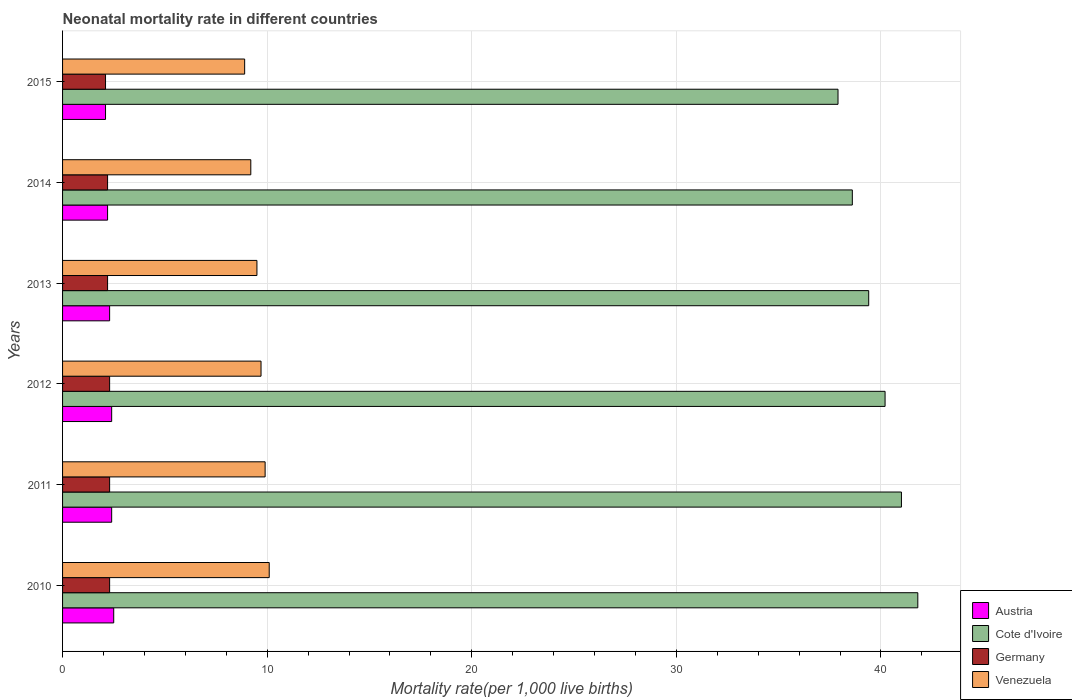Are the number of bars on each tick of the Y-axis equal?
Give a very brief answer. Yes. How many bars are there on the 1st tick from the bottom?
Your response must be concise. 4. What is the label of the 5th group of bars from the top?
Your answer should be compact. 2011. In how many cases, is the number of bars for a given year not equal to the number of legend labels?
Give a very brief answer. 0. What is the neonatal mortality rate in Cote d'Ivoire in 2011?
Offer a terse response. 41. Across all years, what is the minimum neonatal mortality rate in Cote d'Ivoire?
Keep it short and to the point. 37.9. In which year was the neonatal mortality rate in Cote d'Ivoire minimum?
Make the answer very short. 2015. What is the total neonatal mortality rate in Cote d'Ivoire in the graph?
Ensure brevity in your answer.  238.9. What is the difference between the neonatal mortality rate in Cote d'Ivoire in 2012 and that in 2013?
Provide a short and direct response. 0.8. What is the difference between the neonatal mortality rate in Venezuela in 2010 and the neonatal mortality rate in Austria in 2011?
Provide a succinct answer. 7.7. What is the average neonatal mortality rate in Venezuela per year?
Give a very brief answer. 9.55. In the year 2012, what is the difference between the neonatal mortality rate in Cote d'Ivoire and neonatal mortality rate in Germany?
Make the answer very short. 37.9. What is the ratio of the neonatal mortality rate in Austria in 2010 to that in 2011?
Give a very brief answer. 1.04. Is the neonatal mortality rate in Germany in 2010 less than that in 2015?
Your answer should be very brief. No. Is the difference between the neonatal mortality rate in Cote d'Ivoire in 2011 and 2013 greater than the difference between the neonatal mortality rate in Germany in 2011 and 2013?
Give a very brief answer. Yes. What is the difference between the highest and the second highest neonatal mortality rate in Cote d'Ivoire?
Make the answer very short. 0.8. What is the difference between the highest and the lowest neonatal mortality rate in Cote d'Ivoire?
Your answer should be compact. 3.9. In how many years, is the neonatal mortality rate in Cote d'Ivoire greater than the average neonatal mortality rate in Cote d'Ivoire taken over all years?
Keep it short and to the point. 3. Is it the case that in every year, the sum of the neonatal mortality rate in Venezuela and neonatal mortality rate in Germany is greater than the sum of neonatal mortality rate in Austria and neonatal mortality rate in Cote d'Ivoire?
Your response must be concise. Yes. What does the 3rd bar from the bottom in 2012 represents?
Give a very brief answer. Germany. Are all the bars in the graph horizontal?
Provide a short and direct response. Yes. How many years are there in the graph?
Give a very brief answer. 6. What is the difference between two consecutive major ticks on the X-axis?
Make the answer very short. 10. Does the graph contain any zero values?
Give a very brief answer. No. What is the title of the graph?
Your response must be concise. Neonatal mortality rate in different countries. What is the label or title of the X-axis?
Ensure brevity in your answer.  Mortality rate(per 1,0 live births). What is the Mortality rate(per 1,000 live births) of Cote d'Ivoire in 2010?
Give a very brief answer. 41.8. What is the Mortality rate(per 1,000 live births) of Germany in 2010?
Your answer should be very brief. 2.3. What is the Mortality rate(per 1,000 live births) of Cote d'Ivoire in 2011?
Your response must be concise. 41. What is the Mortality rate(per 1,000 live births) of Germany in 2011?
Keep it short and to the point. 2.3. What is the Mortality rate(per 1,000 live births) of Cote d'Ivoire in 2012?
Offer a terse response. 40.2. What is the Mortality rate(per 1,000 live births) of Germany in 2012?
Make the answer very short. 2.3. What is the Mortality rate(per 1,000 live births) in Cote d'Ivoire in 2013?
Make the answer very short. 39.4. What is the Mortality rate(per 1,000 live births) of Germany in 2013?
Your answer should be compact. 2.2. What is the Mortality rate(per 1,000 live births) in Venezuela in 2013?
Make the answer very short. 9.5. What is the Mortality rate(per 1,000 live births) of Cote d'Ivoire in 2014?
Your answer should be compact. 38.6. What is the Mortality rate(per 1,000 live births) of Cote d'Ivoire in 2015?
Offer a very short reply. 37.9. What is the Mortality rate(per 1,000 live births) of Germany in 2015?
Offer a very short reply. 2.1. What is the Mortality rate(per 1,000 live births) of Venezuela in 2015?
Provide a succinct answer. 8.9. Across all years, what is the maximum Mortality rate(per 1,000 live births) of Austria?
Give a very brief answer. 2.5. Across all years, what is the maximum Mortality rate(per 1,000 live births) in Cote d'Ivoire?
Offer a terse response. 41.8. Across all years, what is the maximum Mortality rate(per 1,000 live births) in Germany?
Provide a succinct answer. 2.3. Across all years, what is the maximum Mortality rate(per 1,000 live births) of Venezuela?
Make the answer very short. 10.1. Across all years, what is the minimum Mortality rate(per 1,000 live births) in Austria?
Make the answer very short. 2.1. Across all years, what is the minimum Mortality rate(per 1,000 live births) in Cote d'Ivoire?
Provide a succinct answer. 37.9. Across all years, what is the minimum Mortality rate(per 1,000 live births) of Venezuela?
Your response must be concise. 8.9. What is the total Mortality rate(per 1,000 live births) of Cote d'Ivoire in the graph?
Ensure brevity in your answer.  238.9. What is the total Mortality rate(per 1,000 live births) of Venezuela in the graph?
Your answer should be compact. 57.3. What is the difference between the Mortality rate(per 1,000 live births) of Germany in 2010 and that in 2011?
Provide a succinct answer. 0. What is the difference between the Mortality rate(per 1,000 live births) of Austria in 2010 and that in 2012?
Give a very brief answer. 0.1. What is the difference between the Mortality rate(per 1,000 live births) of Cote d'Ivoire in 2010 and that in 2012?
Make the answer very short. 1.6. What is the difference between the Mortality rate(per 1,000 live births) in Venezuela in 2010 and that in 2012?
Ensure brevity in your answer.  0.4. What is the difference between the Mortality rate(per 1,000 live births) in Germany in 2010 and that in 2013?
Keep it short and to the point. 0.1. What is the difference between the Mortality rate(per 1,000 live births) of Cote d'Ivoire in 2010 and that in 2014?
Provide a succinct answer. 3.2. What is the difference between the Mortality rate(per 1,000 live births) in Germany in 2010 and that in 2014?
Your answer should be very brief. 0.1. What is the difference between the Mortality rate(per 1,000 live births) in Venezuela in 2010 and that in 2014?
Offer a terse response. 0.9. What is the difference between the Mortality rate(per 1,000 live births) in Austria in 2010 and that in 2015?
Make the answer very short. 0.4. What is the difference between the Mortality rate(per 1,000 live births) in Germany in 2010 and that in 2015?
Your response must be concise. 0.2. What is the difference between the Mortality rate(per 1,000 live births) in Austria in 2011 and that in 2013?
Keep it short and to the point. 0.1. What is the difference between the Mortality rate(per 1,000 live births) in Germany in 2011 and that in 2013?
Provide a succinct answer. 0.1. What is the difference between the Mortality rate(per 1,000 live births) in Venezuela in 2011 and that in 2013?
Ensure brevity in your answer.  0.4. What is the difference between the Mortality rate(per 1,000 live births) in Cote d'Ivoire in 2011 and that in 2014?
Give a very brief answer. 2.4. What is the difference between the Mortality rate(per 1,000 live births) of Germany in 2011 and that in 2014?
Give a very brief answer. 0.1. What is the difference between the Mortality rate(per 1,000 live births) of Cote d'Ivoire in 2011 and that in 2015?
Provide a succinct answer. 3.1. What is the difference between the Mortality rate(per 1,000 live births) in Venezuela in 2011 and that in 2015?
Offer a very short reply. 1. What is the difference between the Mortality rate(per 1,000 live births) of Cote d'Ivoire in 2012 and that in 2013?
Give a very brief answer. 0.8. What is the difference between the Mortality rate(per 1,000 live births) of Germany in 2012 and that in 2013?
Keep it short and to the point. 0.1. What is the difference between the Mortality rate(per 1,000 live births) of Venezuela in 2012 and that in 2013?
Make the answer very short. 0.2. What is the difference between the Mortality rate(per 1,000 live births) of Austria in 2012 and that in 2014?
Your answer should be compact. 0.2. What is the difference between the Mortality rate(per 1,000 live births) in Cote d'Ivoire in 2012 and that in 2014?
Your response must be concise. 1.6. What is the difference between the Mortality rate(per 1,000 live births) in Germany in 2012 and that in 2014?
Provide a short and direct response. 0.1. What is the difference between the Mortality rate(per 1,000 live births) of Venezuela in 2012 and that in 2014?
Your answer should be compact. 0.5. What is the difference between the Mortality rate(per 1,000 live births) in Cote d'Ivoire in 2012 and that in 2015?
Provide a short and direct response. 2.3. What is the difference between the Mortality rate(per 1,000 live births) of Germany in 2012 and that in 2015?
Your response must be concise. 0.2. What is the difference between the Mortality rate(per 1,000 live births) in Cote d'Ivoire in 2013 and that in 2014?
Your response must be concise. 0.8. What is the difference between the Mortality rate(per 1,000 live births) of Germany in 2013 and that in 2014?
Your response must be concise. 0. What is the difference between the Mortality rate(per 1,000 live births) of Venezuela in 2013 and that in 2014?
Provide a short and direct response. 0.3. What is the difference between the Mortality rate(per 1,000 live births) in Cote d'Ivoire in 2013 and that in 2015?
Your response must be concise. 1.5. What is the difference between the Mortality rate(per 1,000 live births) of Venezuela in 2013 and that in 2015?
Keep it short and to the point. 0.6. What is the difference between the Mortality rate(per 1,000 live births) in Germany in 2014 and that in 2015?
Provide a succinct answer. 0.1. What is the difference between the Mortality rate(per 1,000 live births) in Venezuela in 2014 and that in 2015?
Provide a short and direct response. 0.3. What is the difference between the Mortality rate(per 1,000 live births) in Austria in 2010 and the Mortality rate(per 1,000 live births) in Cote d'Ivoire in 2011?
Your answer should be compact. -38.5. What is the difference between the Mortality rate(per 1,000 live births) of Austria in 2010 and the Mortality rate(per 1,000 live births) of Germany in 2011?
Offer a terse response. 0.2. What is the difference between the Mortality rate(per 1,000 live births) of Cote d'Ivoire in 2010 and the Mortality rate(per 1,000 live births) of Germany in 2011?
Your answer should be compact. 39.5. What is the difference between the Mortality rate(per 1,000 live births) in Cote d'Ivoire in 2010 and the Mortality rate(per 1,000 live births) in Venezuela in 2011?
Provide a short and direct response. 31.9. What is the difference between the Mortality rate(per 1,000 live births) of Austria in 2010 and the Mortality rate(per 1,000 live births) of Cote d'Ivoire in 2012?
Your response must be concise. -37.7. What is the difference between the Mortality rate(per 1,000 live births) of Austria in 2010 and the Mortality rate(per 1,000 live births) of Venezuela in 2012?
Make the answer very short. -7.2. What is the difference between the Mortality rate(per 1,000 live births) of Cote d'Ivoire in 2010 and the Mortality rate(per 1,000 live births) of Germany in 2012?
Make the answer very short. 39.5. What is the difference between the Mortality rate(per 1,000 live births) in Cote d'Ivoire in 2010 and the Mortality rate(per 1,000 live births) in Venezuela in 2012?
Your answer should be very brief. 32.1. What is the difference between the Mortality rate(per 1,000 live births) in Austria in 2010 and the Mortality rate(per 1,000 live births) in Cote d'Ivoire in 2013?
Provide a succinct answer. -36.9. What is the difference between the Mortality rate(per 1,000 live births) of Austria in 2010 and the Mortality rate(per 1,000 live births) of Germany in 2013?
Your answer should be compact. 0.3. What is the difference between the Mortality rate(per 1,000 live births) in Cote d'Ivoire in 2010 and the Mortality rate(per 1,000 live births) in Germany in 2013?
Your answer should be very brief. 39.6. What is the difference between the Mortality rate(per 1,000 live births) of Cote d'Ivoire in 2010 and the Mortality rate(per 1,000 live births) of Venezuela in 2013?
Ensure brevity in your answer.  32.3. What is the difference between the Mortality rate(per 1,000 live births) of Austria in 2010 and the Mortality rate(per 1,000 live births) of Cote d'Ivoire in 2014?
Provide a succinct answer. -36.1. What is the difference between the Mortality rate(per 1,000 live births) in Austria in 2010 and the Mortality rate(per 1,000 live births) in Germany in 2014?
Your response must be concise. 0.3. What is the difference between the Mortality rate(per 1,000 live births) in Cote d'Ivoire in 2010 and the Mortality rate(per 1,000 live births) in Germany in 2014?
Make the answer very short. 39.6. What is the difference between the Mortality rate(per 1,000 live births) of Cote d'Ivoire in 2010 and the Mortality rate(per 1,000 live births) of Venezuela in 2014?
Keep it short and to the point. 32.6. What is the difference between the Mortality rate(per 1,000 live births) in Austria in 2010 and the Mortality rate(per 1,000 live births) in Cote d'Ivoire in 2015?
Keep it short and to the point. -35.4. What is the difference between the Mortality rate(per 1,000 live births) of Austria in 2010 and the Mortality rate(per 1,000 live births) of Germany in 2015?
Provide a succinct answer. 0.4. What is the difference between the Mortality rate(per 1,000 live births) in Austria in 2010 and the Mortality rate(per 1,000 live births) in Venezuela in 2015?
Offer a terse response. -6.4. What is the difference between the Mortality rate(per 1,000 live births) in Cote d'Ivoire in 2010 and the Mortality rate(per 1,000 live births) in Germany in 2015?
Provide a short and direct response. 39.7. What is the difference between the Mortality rate(per 1,000 live births) of Cote d'Ivoire in 2010 and the Mortality rate(per 1,000 live births) of Venezuela in 2015?
Your answer should be compact. 32.9. What is the difference between the Mortality rate(per 1,000 live births) in Germany in 2010 and the Mortality rate(per 1,000 live births) in Venezuela in 2015?
Your response must be concise. -6.6. What is the difference between the Mortality rate(per 1,000 live births) of Austria in 2011 and the Mortality rate(per 1,000 live births) of Cote d'Ivoire in 2012?
Provide a short and direct response. -37.8. What is the difference between the Mortality rate(per 1,000 live births) of Cote d'Ivoire in 2011 and the Mortality rate(per 1,000 live births) of Germany in 2012?
Provide a short and direct response. 38.7. What is the difference between the Mortality rate(per 1,000 live births) of Cote d'Ivoire in 2011 and the Mortality rate(per 1,000 live births) of Venezuela in 2012?
Provide a short and direct response. 31.3. What is the difference between the Mortality rate(per 1,000 live births) of Germany in 2011 and the Mortality rate(per 1,000 live births) of Venezuela in 2012?
Provide a succinct answer. -7.4. What is the difference between the Mortality rate(per 1,000 live births) of Austria in 2011 and the Mortality rate(per 1,000 live births) of Cote d'Ivoire in 2013?
Keep it short and to the point. -37. What is the difference between the Mortality rate(per 1,000 live births) of Cote d'Ivoire in 2011 and the Mortality rate(per 1,000 live births) of Germany in 2013?
Provide a succinct answer. 38.8. What is the difference between the Mortality rate(per 1,000 live births) of Cote d'Ivoire in 2011 and the Mortality rate(per 1,000 live births) of Venezuela in 2013?
Ensure brevity in your answer.  31.5. What is the difference between the Mortality rate(per 1,000 live births) in Germany in 2011 and the Mortality rate(per 1,000 live births) in Venezuela in 2013?
Provide a succinct answer. -7.2. What is the difference between the Mortality rate(per 1,000 live births) of Austria in 2011 and the Mortality rate(per 1,000 live births) of Cote d'Ivoire in 2014?
Give a very brief answer. -36.2. What is the difference between the Mortality rate(per 1,000 live births) of Cote d'Ivoire in 2011 and the Mortality rate(per 1,000 live births) of Germany in 2014?
Offer a very short reply. 38.8. What is the difference between the Mortality rate(per 1,000 live births) of Cote d'Ivoire in 2011 and the Mortality rate(per 1,000 live births) of Venezuela in 2014?
Your response must be concise. 31.8. What is the difference between the Mortality rate(per 1,000 live births) in Germany in 2011 and the Mortality rate(per 1,000 live births) in Venezuela in 2014?
Offer a terse response. -6.9. What is the difference between the Mortality rate(per 1,000 live births) of Austria in 2011 and the Mortality rate(per 1,000 live births) of Cote d'Ivoire in 2015?
Give a very brief answer. -35.5. What is the difference between the Mortality rate(per 1,000 live births) in Austria in 2011 and the Mortality rate(per 1,000 live births) in Germany in 2015?
Your answer should be compact. 0.3. What is the difference between the Mortality rate(per 1,000 live births) of Austria in 2011 and the Mortality rate(per 1,000 live births) of Venezuela in 2015?
Ensure brevity in your answer.  -6.5. What is the difference between the Mortality rate(per 1,000 live births) of Cote d'Ivoire in 2011 and the Mortality rate(per 1,000 live births) of Germany in 2015?
Offer a terse response. 38.9. What is the difference between the Mortality rate(per 1,000 live births) of Cote d'Ivoire in 2011 and the Mortality rate(per 1,000 live births) of Venezuela in 2015?
Keep it short and to the point. 32.1. What is the difference between the Mortality rate(per 1,000 live births) of Germany in 2011 and the Mortality rate(per 1,000 live births) of Venezuela in 2015?
Your response must be concise. -6.6. What is the difference between the Mortality rate(per 1,000 live births) in Austria in 2012 and the Mortality rate(per 1,000 live births) in Cote d'Ivoire in 2013?
Provide a short and direct response. -37. What is the difference between the Mortality rate(per 1,000 live births) in Cote d'Ivoire in 2012 and the Mortality rate(per 1,000 live births) in Venezuela in 2013?
Keep it short and to the point. 30.7. What is the difference between the Mortality rate(per 1,000 live births) of Austria in 2012 and the Mortality rate(per 1,000 live births) of Cote d'Ivoire in 2014?
Offer a terse response. -36.2. What is the difference between the Mortality rate(per 1,000 live births) of Austria in 2012 and the Mortality rate(per 1,000 live births) of Germany in 2014?
Your answer should be very brief. 0.2. What is the difference between the Mortality rate(per 1,000 live births) of Austria in 2012 and the Mortality rate(per 1,000 live births) of Venezuela in 2014?
Provide a succinct answer. -6.8. What is the difference between the Mortality rate(per 1,000 live births) in Cote d'Ivoire in 2012 and the Mortality rate(per 1,000 live births) in Germany in 2014?
Give a very brief answer. 38. What is the difference between the Mortality rate(per 1,000 live births) in Austria in 2012 and the Mortality rate(per 1,000 live births) in Cote d'Ivoire in 2015?
Offer a very short reply. -35.5. What is the difference between the Mortality rate(per 1,000 live births) in Austria in 2012 and the Mortality rate(per 1,000 live births) in Germany in 2015?
Keep it short and to the point. 0.3. What is the difference between the Mortality rate(per 1,000 live births) in Austria in 2012 and the Mortality rate(per 1,000 live births) in Venezuela in 2015?
Make the answer very short. -6.5. What is the difference between the Mortality rate(per 1,000 live births) in Cote d'Ivoire in 2012 and the Mortality rate(per 1,000 live births) in Germany in 2015?
Provide a succinct answer. 38.1. What is the difference between the Mortality rate(per 1,000 live births) in Cote d'Ivoire in 2012 and the Mortality rate(per 1,000 live births) in Venezuela in 2015?
Keep it short and to the point. 31.3. What is the difference between the Mortality rate(per 1,000 live births) in Germany in 2012 and the Mortality rate(per 1,000 live births) in Venezuela in 2015?
Offer a very short reply. -6.6. What is the difference between the Mortality rate(per 1,000 live births) of Austria in 2013 and the Mortality rate(per 1,000 live births) of Cote d'Ivoire in 2014?
Keep it short and to the point. -36.3. What is the difference between the Mortality rate(per 1,000 live births) of Austria in 2013 and the Mortality rate(per 1,000 live births) of Germany in 2014?
Provide a short and direct response. 0.1. What is the difference between the Mortality rate(per 1,000 live births) in Austria in 2013 and the Mortality rate(per 1,000 live births) in Venezuela in 2014?
Provide a short and direct response. -6.9. What is the difference between the Mortality rate(per 1,000 live births) in Cote d'Ivoire in 2013 and the Mortality rate(per 1,000 live births) in Germany in 2014?
Provide a succinct answer. 37.2. What is the difference between the Mortality rate(per 1,000 live births) in Cote d'Ivoire in 2013 and the Mortality rate(per 1,000 live births) in Venezuela in 2014?
Offer a terse response. 30.2. What is the difference between the Mortality rate(per 1,000 live births) in Austria in 2013 and the Mortality rate(per 1,000 live births) in Cote d'Ivoire in 2015?
Your response must be concise. -35.6. What is the difference between the Mortality rate(per 1,000 live births) of Austria in 2013 and the Mortality rate(per 1,000 live births) of Germany in 2015?
Keep it short and to the point. 0.2. What is the difference between the Mortality rate(per 1,000 live births) in Cote d'Ivoire in 2013 and the Mortality rate(per 1,000 live births) in Germany in 2015?
Make the answer very short. 37.3. What is the difference between the Mortality rate(per 1,000 live births) in Cote d'Ivoire in 2013 and the Mortality rate(per 1,000 live births) in Venezuela in 2015?
Provide a short and direct response. 30.5. What is the difference between the Mortality rate(per 1,000 live births) in Austria in 2014 and the Mortality rate(per 1,000 live births) in Cote d'Ivoire in 2015?
Provide a succinct answer. -35.7. What is the difference between the Mortality rate(per 1,000 live births) in Austria in 2014 and the Mortality rate(per 1,000 live births) in Germany in 2015?
Your answer should be compact. 0.1. What is the difference between the Mortality rate(per 1,000 live births) in Cote d'Ivoire in 2014 and the Mortality rate(per 1,000 live births) in Germany in 2015?
Give a very brief answer. 36.5. What is the difference between the Mortality rate(per 1,000 live births) in Cote d'Ivoire in 2014 and the Mortality rate(per 1,000 live births) in Venezuela in 2015?
Keep it short and to the point. 29.7. What is the average Mortality rate(per 1,000 live births) of Austria per year?
Make the answer very short. 2.32. What is the average Mortality rate(per 1,000 live births) of Cote d'Ivoire per year?
Your response must be concise. 39.82. What is the average Mortality rate(per 1,000 live births) in Germany per year?
Provide a succinct answer. 2.23. What is the average Mortality rate(per 1,000 live births) of Venezuela per year?
Give a very brief answer. 9.55. In the year 2010, what is the difference between the Mortality rate(per 1,000 live births) of Austria and Mortality rate(per 1,000 live births) of Cote d'Ivoire?
Provide a succinct answer. -39.3. In the year 2010, what is the difference between the Mortality rate(per 1,000 live births) of Austria and Mortality rate(per 1,000 live births) of Germany?
Keep it short and to the point. 0.2. In the year 2010, what is the difference between the Mortality rate(per 1,000 live births) in Cote d'Ivoire and Mortality rate(per 1,000 live births) in Germany?
Your response must be concise. 39.5. In the year 2010, what is the difference between the Mortality rate(per 1,000 live births) in Cote d'Ivoire and Mortality rate(per 1,000 live births) in Venezuela?
Your response must be concise. 31.7. In the year 2010, what is the difference between the Mortality rate(per 1,000 live births) in Germany and Mortality rate(per 1,000 live births) in Venezuela?
Keep it short and to the point. -7.8. In the year 2011, what is the difference between the Mortality rate(per 1,000 live births) in Austria and Mortality rate(per 1,000 live births) in Cote d'Ivoire?
Provide a short and direct response. -38.6. In the year 2011, what is the difference between the Mortality rate(per 1,000 live births) of Cote d'Ivoire and Mortality rate(per 1,000 live births) of Germany?
Offer a very short reply. 38.7. In the year 2011, what is the difference between the Mortality rate(per 1,000 live births) in Cote d'Ivoire and Mortality rate(per 1,000 live births) in Venezuela?
Keep it short and to the point. 31.1. In the year 2012, what is the difference between the Mortality rate(per 1,000 live births) in Austria and Mortality rate(per 1,000 live births) in Cote d'Ivoire?
Your response must be concise. -37.8. In the year 2012, what is the difference between the Mortality rate(per 1,000 live births) of Austria and Mortality rate(per 1,000 live births) of Germany?
Provide a short and direct response. 0.1. In the year 2012, what is the difference between the Mortality rate(per 1,000 live births) of Austria and Mortality rate(per 1,000 live births) of Venezuela?
Your answer should be compact. -7.3. In the year 2012, what is the difference between the Mortality rate(per 1,000 live births) of Cote d'Ivoire and Mortality rate(per 1,000 live births) of Germany?
Offer a very short reply. 37.9. In the year 2012, what is the difference between the Mortality rate(per 1,000 live births) in Cote d'Ivoire and Mortality rate(per 1,000 live births) in Venezuela?
Offer a very short reply. 30.5. In the year 2013, what is the difference between the Mortality rate(per 1,000 live births) in Austria and Mortality rate(per 1,000 live births) in Cote d'Ivoire?
Your answer should be very brief. -37.1. In the year 2013, what is the difference between the Mortality rate(per 1,000 live births) of Austria and Mortality rate(per 1,000 live births) of Germany?
Give a very brief answer. 0.1. In the year 2013, what is the difference between the Mortality rate(per 1,000 live births) of Austria and Mortality rate(per 1,000 live births) of Venezuela?
Make the answer very short. -7.2. In the year 2013, what is the difference between the Mortality rate(per 1,000 live births) of Cote d'Ivoire and Mortality rate(per 1,000 live births) of Germany?
Provide a succinct answer. 37.2. In the year 2013, what is the difference between the Mortality rate(per 1,000 live births) of Cote d'Ivoire and Mortality rate(per 1,000 live births) of Venezuela?
Give a very brief answer. 29.9. In the year 2013, what is the difference between the Mortality rate(per 1,000 live births) of Germany and Mortality rate(per 1,000 live births) of Venezuela?
Offer a very short reply. -7.3. In the year 2014, what is the difference between the Mortality rate(per 1,000 live births) in Austria and Mortality rate(per 1,000 live births) in Cote d'Ivoire?
Offer a terse response. -36.4. In the year 2014, what is the difference between the Mortality rate(per 1,000 live births) of Cote d'Ivoire and Mortality rate(per 1,000 live births) of Germany?
Provide a short and direct response. 36.4. In the year 2014, what is the difference between the Mortality rate(per 1,000 live births) of Cote d'Ivoire and Mortality rate(per 1,000 live births) of Venezuela?
Provide a short and direct response. 29.4. In the year 2014, what is the difference between the Mortality rate(per 1,000 live births) of Germany and Mortality rate(per 1,000 live births) of Venezuela?
Provide a short and direct response. -7. In the year 2015, what is the difference between the Mortality rate(per 1,000 live births) in Austria and Mortality rate(per 1,000 live births) in Cote d'Ivoire?
Your answer should be compact. -35.8. In the year 2015, what is the difference between the Mortality rate(per 1,000 live births) in Cote d'Ivoire and Mortality rate(per 1,000 live births) in Germany?
Offer a terse response. 35.8. What is the ratio of the Mortality rate(per 1,000 live births) of Austria in 2010 to that in 2011?
Provide a succinct answer. 1.04. What is the ratio of the Mortality rate(per 1,000 live births) in Cote d'Ivoire in 2010 to that in 2011?
Provide a succinct answer. 1.02. What is the ratio of the Mortality rate(per 1,000 live births) of Venezuela in 2010 to that in 2011?
Offer a terse response. 1.02. What is the ratio of the Mortality rate(per 1,000 live births) of Austria in 2010 to that in 2012?
Provide a succinct answer. 1.04. What is the ratio of the Mortality rate(per 1,000 live births) in Cote d'Ivoire in 2010 to that in 2012?
Ensure brevity in your answer.  1.04. What is the ratio of the Mortality rate(per 1,000 live births) in Venezuela in 2010 to that in 2012?
Ensure brevity in your answer.  1.04. What is the ratio of the Mortality rate(per 1,000 live births) of Austria in 2010 to that in 2013?
Provide a succinct answer. 1.09. What is the ratio of the Mortality rate(per 1,000 live births) in Cote d'Ivoire in 2010 to that in 2013?
Your answer should be compact. 1.06. What is the ratio of the Mortality rate(per 1,000 live births) of Germany in 2010 to that in 2013?
Make the answer very short. 1.05. What is the ratio of the Mortality rate(per 1,000 live births) of Venezuela in 2010 to that in 2013?
Keep it short and to the point. 1.06. What is the ratio of the Mortality rate(per 1,000 live births) in Austria in 2010 to that in 2014?
Your answer should be very brief. 1.14. What is the ratio of the Mortality rate(per 1,000 live births) of Cote d'Ivoire in 2010 to that in 2014?
Your answer should be very brief. 1.08. What is the ratio of the Mortality rate(per 1,000 live births) in Germany in 2010 to that in 2014?
Ensure brevity in your answer.  1.05. What is the ratio of the Mortality rate(per 1,000 live births) of Venezuela in 2010 to that in 2014?
Ensure brevity in your answer.  1.1. What is the ratio of the Mortality rate(per 1,000 live births) in Austria in 2010 to that in 2015?
Ensure brevity in your answer.  1.19. What is the ratio of the Mortality rate(per 1,000 live births) of Cote d'Ivoire in 2010 to that in 2015?
Make the answer very short. 1.1. What is the ratio of the Mortality rate(per 1,000 live births) in Germany in 2010 to that in 2015?
Your response must be concise. 1.1. What is the ratio of the Mortality rate(per 1,000 live births) in Venezuela in 2010 to that in 2015?
Your answer should be compact. 1.13. What is the ratio of the Mortality rate(per 1,000 live births) of Austria in 2011 to that in 2012?
Keep it short and to the point. 1. What is the ratio of the Mortality rate(per 1,000 live births) of Cote d'Ivoire in 2011 to that in 2012?
Offer a terse response. 1.02. What is the ratio of the Mortality rate(per 1,000 live births) in Germany in 2011 to that in 2012?
Give a very brief answer. 1. What is the ratio of the Mortality rate(per 1,000 live births) of Venezuela in 2011 to that in 2012?
Your answer should be very brief. 1.02. What is the ratio of the Mortality rate(per 1,000 live births) of Austria in 2011 to that in 2013?
Give a very brief answer. 1.04. What is the ratio of the Mortality rate(per 1,000 live births) in Cote d'Ivoire in 2011 to that in 2013?
Your response must be concise. 1.04. What is the ratio of the Mortality rate(per 1,000 live births) in Germany in 2011 to that in 2013?
Provide a short and direct response. 1.05. What is the ratio of the Mortality rate(per 1,000 live births) of Venezuela in 2011 to that in 2013?
Your answer should be very brief. 1.04. What is the ratio of the Mortality rate(per 1,000 live births) in Cote d'Ivoire in 2011 to that in 2014?
Keep it short and to the point. 1.06. What is the ratio of the Mortality rate(per 1,000 live births) of Germany in 2011 to that in 2014?
Offer a very short reply. 1.05. What is the ratio of the Mortality rate(per 1,000 live births) in Venezuela in 2011 to that in 2014?
Your answer should be compact. 1.08. What is the ratio of the Mortality rate(per 1,000 live births) of Austria in 2011 to that in 2015?
Keep it short and to the point. 1.14. What is the ratio of the Mortality rate(per 1,000 live births) in Cote d'Ivoire in 2011 to that in 2015?
Provide a succinct answer. 1.08. What is the ratio of the Mortality rate(per 1,000 live births) in Germany in 2011 to that in 2015?
Keep it short and to the point. 1.1. What is the ratio of the Mortality rate(per 1,000 live births) of Venezuela in 2011 to that in 2015?
Your response must be concise. 1.11. What is the ratio of the Mortality rate(per 1,000 live births) of Austria in 2012 to that in 2013?
Offer a terse response. 1.04. What is the ratio of the Mortality rate(per 1,000 live births) in Cote d'Ivoire in 2012 to that in 2013?
Your answer should be compact. 1.02. What is the ratio of the Mortality rate(per 1,000 live births) of Germany in 2012 to that in 2013?
Ensure brevity in your answer.  1.05. What is the ratio of the Mortality rate(per 1,000 live births) in Venezuela in 2012 to that in 2013?
Your answer should be compact. 1.02. What is the ratio of the Mortality rate(per 1,000 live births) of Cote d'Ivoire in 2012 to that in 2014?
Your answer should be very brief. 1.04. What is the ratio of the Mortality rate(per 1,000 live births) of Germany in 2012 to that in 2014?
Give a very brief answer. 1.05. What is the ratio of the Mortality rate(per 1,000 live births) in Venezuela in 2012 to that in 2014?
Give a very brief answer. 1.05. What is the ratio of the Mortality rate(per 1,000 live births) in Cote d'Ivoire in 2012 to that in 2015?
Give a very brief answer. 1.06. What is the ratio of the Mortality rate(per 1,000 live births) of Germany in 2012 to that in 2015?
Give a very brief answer. 1.1. What is the ratio of the Mortality rate(per 1,000 live births) in Venezuela in 2012 to that in 2015?
Ensure brevity in your answer.  1.09. What is the ratio of the Mortality rate(per 1,000 live births) in Austria in 2013 to that in 2014?
Your response must be concise. 1.05. What is the ratio of the Mortality rate(per 1,000 live births) in Cote d'Ivoire in 2013 to that in 2014?
Ensure brevity in your answer.  1.02. What is the ratio of the Mortality rate(per 1,000 live births) of Venezuela in 2013 to that in 2014?
Your answer should be very brief. 1.03. What is the ratio of the Mortality rate(per 1,000 live births) in Austria in 2013 to that in 2015?
Your answer should be compact. 1.1. What is the ratio of the Mortality rate(per 1,000 live births) in Cote d'Ivoire in 2013 to that in 2015?
Give a very brief answer. 1.04. What is the ratio of the Mortality rate(per 1,000 live births) in Germany in 2013 to that in 2015?
Your answer should be compact. 1.05. What is the ratio of the Mortality rate(per 1,000 live births) of Venezuela in 2013 to that in 2015?
Offer a very short reply. 1.07. What is the ratio of the Mortality rate(per 1,000 live births) of Austria in 2014 to that in 2015?
Provide a succinct answer. 1.05. What is the ratio of the Mortality rate(per 1,000 live births) of Cote d'Ivoire in 2014 to that in 2015?
Provide a short and direct response. 1.02. What is the ratio of the Mortality rate(per 1,000 live births) in Germany in 2014 to that in 2015?
Give a very brief answer. 1.05. What is the ratio of the Mortality rate(per 1,000 live births) in Venezuela in 2014 to that in 2015?
Offer a terse response. 1.03. What is the difference between the highest and the second highest Mortality rate(per 1,000 live births) in Venezuela?
Offer a very short reply. 0.2. What is the difference between the highest and the lowest Mortality rate(per 1,000 live births) of Austria?
Provide a short and direct response. 0.4. What is the difference between the highest and the lowest Mortality rate(per 1,000 live births) in Germany?
Offer a very short reply. 0.2. 